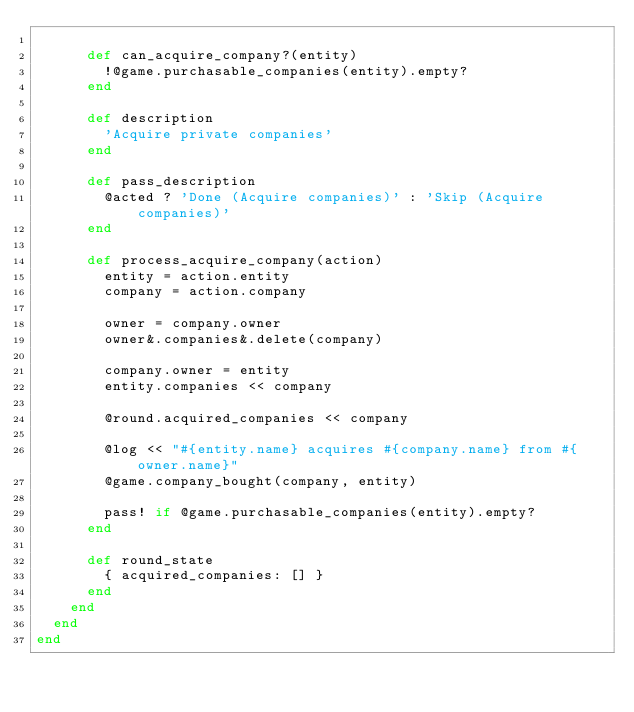Convert code to text. <code><loc_0><loc_0><loc_500><loc_500><_Ruby_>
      def can_acquire_company?(entity)
        !@game.purchasable_companies(entity).empty?
      end

      def description
        'Acquire private companies'
      end

      def pass_description
        @acted ? 'Done (Acquire companies)' : 'Skip (Acquire companies)'
      end

      def process_acquire_company(action)
        entity = action.entity
        company = action.company

        owner = company.owner
        owner&.companies&.delete(company)

        company.owner = entity
        entity.companies << company

        @round.acquired_companies << company

        @log << "#{entity.name} acquires #{company.name} from #{owner.name}"
        @game.company_bought(company, entity)

        pass! if @game.purchasable_companies(entity).empty?
      end

      def round_state
        { acquired_companies: [] }
      end
    end
  end
end
</code> 